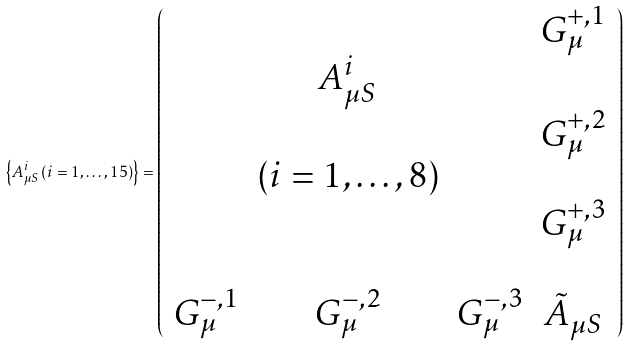<formula> <loc_0><loc_0><loc_500><loc_500>\left \{ A ^ { i } _ { \mu S } \left ( i = 1 , \dots , 1 5 \right ) \right \} = \left ( \begin{array} { c c c c } & & & G ^ { + , 1 } _ { \mu } \\ & A ^ { i } _ { \mu S } & & \\ & & & G ^ { + , 2 } _ { \mu } \\ & ( i = 1 , \dots , 8 ) & & \\ & & & G ^ { + , 3 } _ { \mu } \\ & & & \\ G ^ { - , 1 } _ { \mu } & G ^ { - , 2 } _ { \mu } & G ^ { - , 3 } _ { \mu } & \tilde { A } _ { \mu S } \end{array} \right )</formula> 